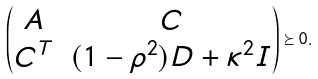Convert formula to latex. <formula><loc_0><loc_0><loc_500><loc_500>\begin{pmatrix} A & C \\ C ^ { T } & ( 1 - \rho ^ { 2 } ) D + \kappa ^ { 2 } I \\ \end{pmatrix} \succeq 0 .</formula> 